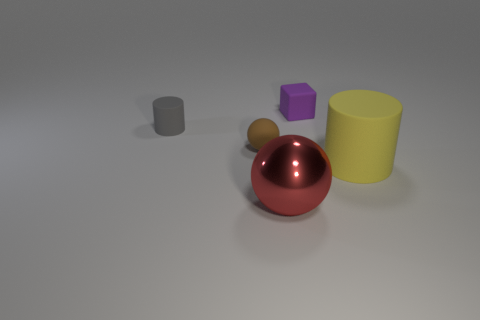Add 1 small purple rubber cylinders. How many objects exist? 6 Subtract all cylinders. How many objects are left? 3 Add 1 small things. How many small things exist? 4 Subtract 0 green spheres. How many objects are left? 5 Subtract all small purple matte blocks. Subtract all small purple rubber blocks. How many objects are left? 3 Add 4 gray cylinders. How many gray cylinders are left? 5 